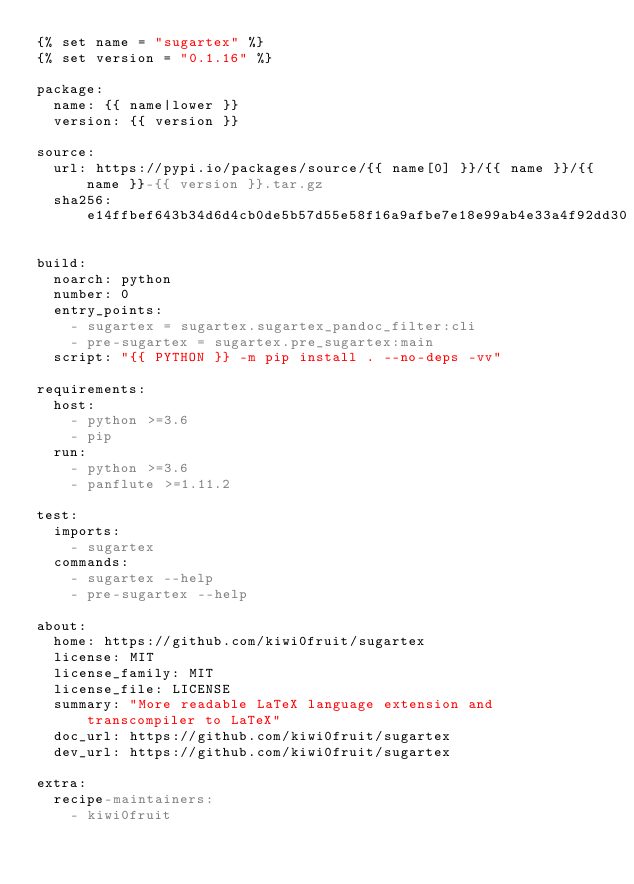Convert code to text. <code><loc_0><loc_0><loc_500><loc_500><_YAML_>{% set name = "sugartex" %}
{% set version = "0.1.16" %}

package:
  name: {{ name|lower }}
  version: {{ version }}

source:
  url: https://pypi.io/packages/source/{{ name[0] }}/{{ name }}/{{ name }}-{{ version }}.tar.gz
  sha256: e14ffbef643b34d6d4cb0de5b57d55e58f16a9afbe7e18e99ab4e33a4f92dd30

build:
  noarch: python
  number: 0
  entry_points:
    - sugartex = sugartex.sugartex_pandoc_filter:cli
    - pre-sugartex = sugartex.pre_sugartex:main
  script: "{{ PYTHON }} -m pip install . --no-deps -vv"

requirements:
  host:
    - python >=3.6
    - pip
  run:
    - python >=3.6
    - panflute >=1.11.2

test:
  imports:
    - sugartex
  commands:
    - sugartex --help
    - pre-sugartex --help

about:
  home: https://github.com/kiwi0fruit/sugartex
  license: MIT
  license_family: MIT
  license_file: LICENSE
  summary: "More readable LaTeX language extension and transcompiler to LaTeX"
  doc_url: https://github.com/kiwi0fruit/sugartex
  dev_url: https://github.com/kiwi0fruit/sugartex

extra:
  recipe-maintainers:
    - kiwi0fruit
</code> 